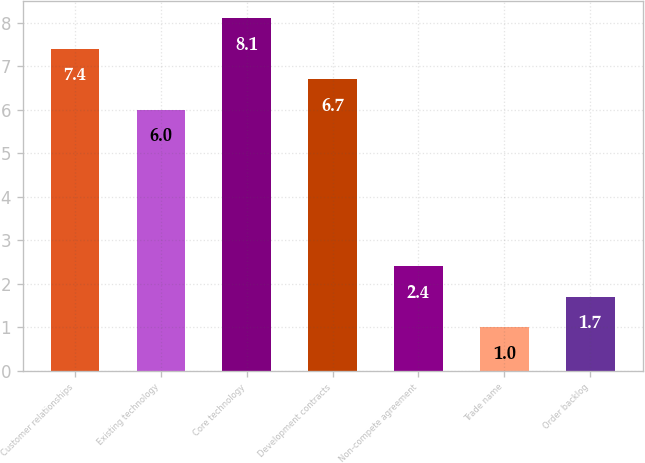Convert chart to OTSL. <chart><loc_0><loc_0><loc_500><loc_500><bar_chart><fcel>Customer relationships<fcel>Existing technology<fcel>Core technology<fcel>Development contracts<fcel>Non-compete agreement<fcel>Trade name<fcel>Order backlog<nl><fcel>7.4<fcel>6<fcel>8.1<fcel>6.7<fcel>2.4<fcel>1<fcel>1.7<nl></chart> 